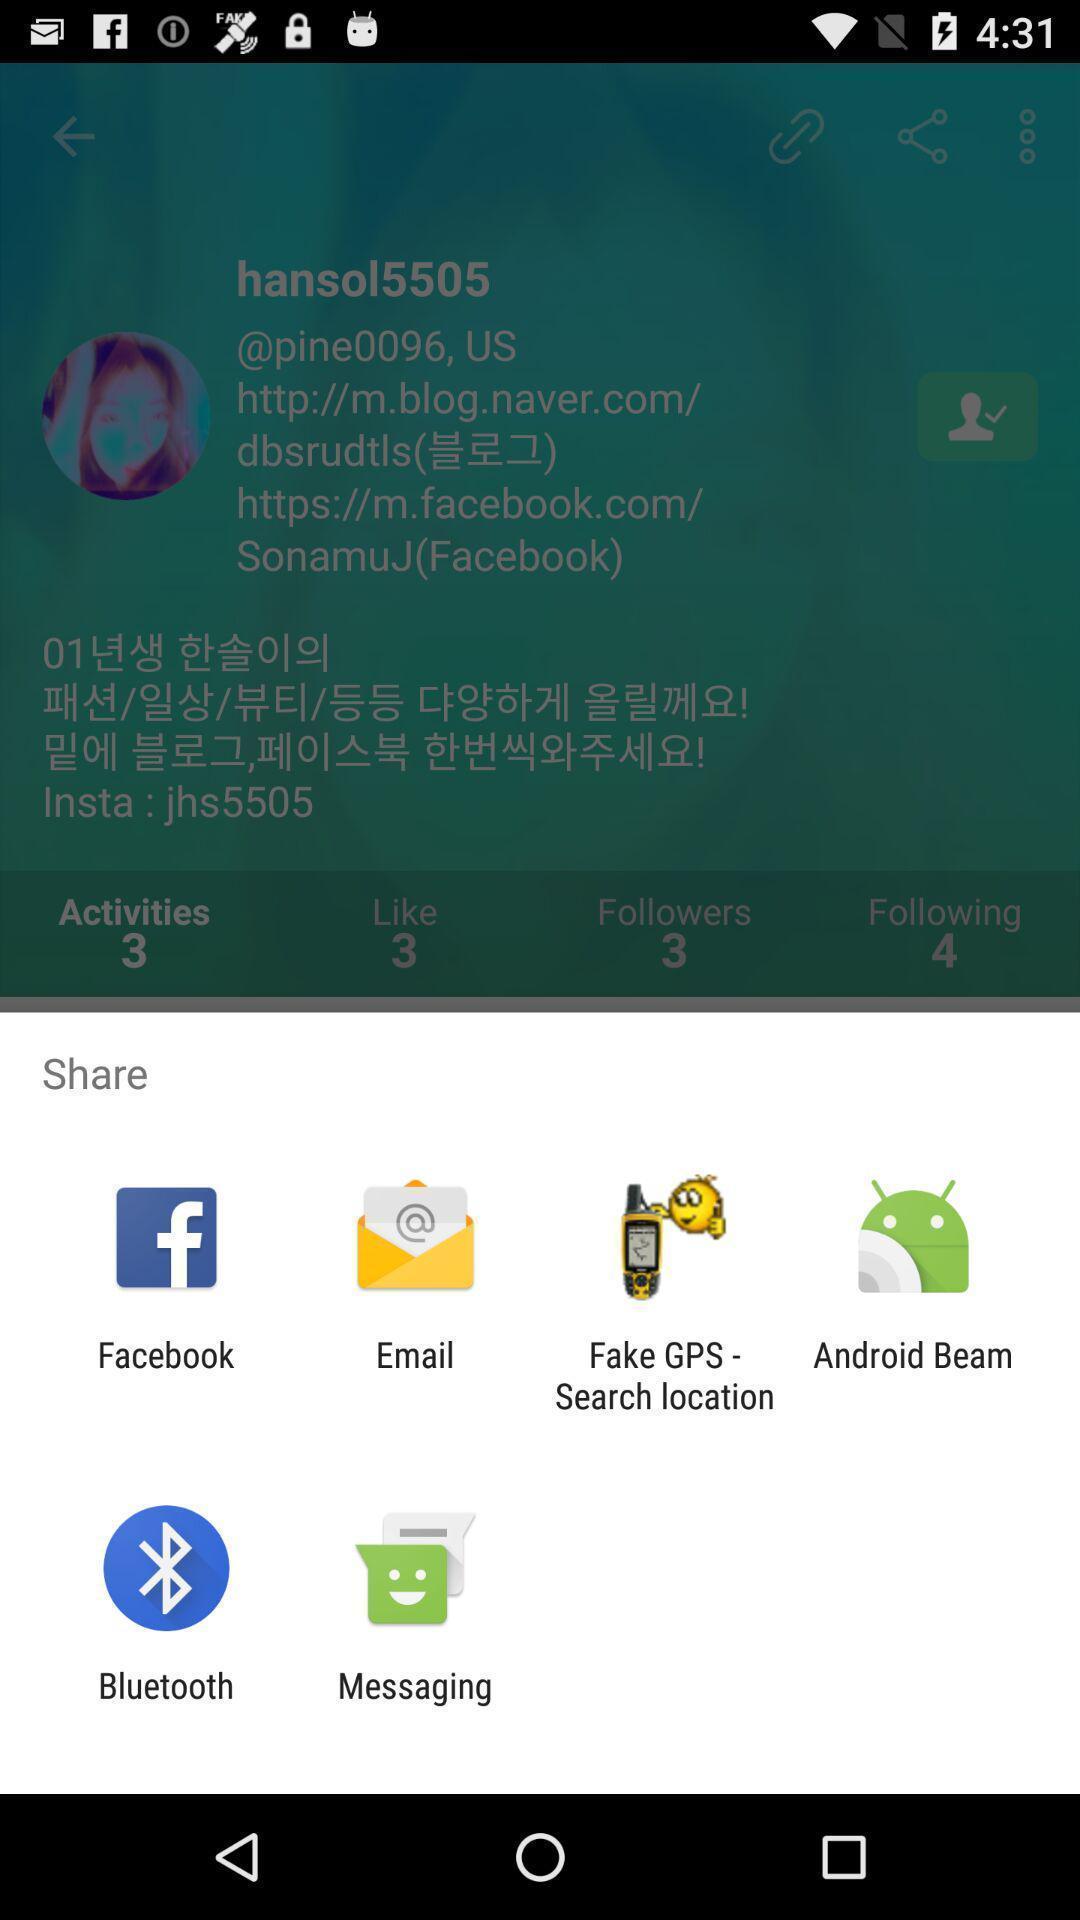Provide a detailed account of this screenshot. Widget showing multiple data sharing apps. 